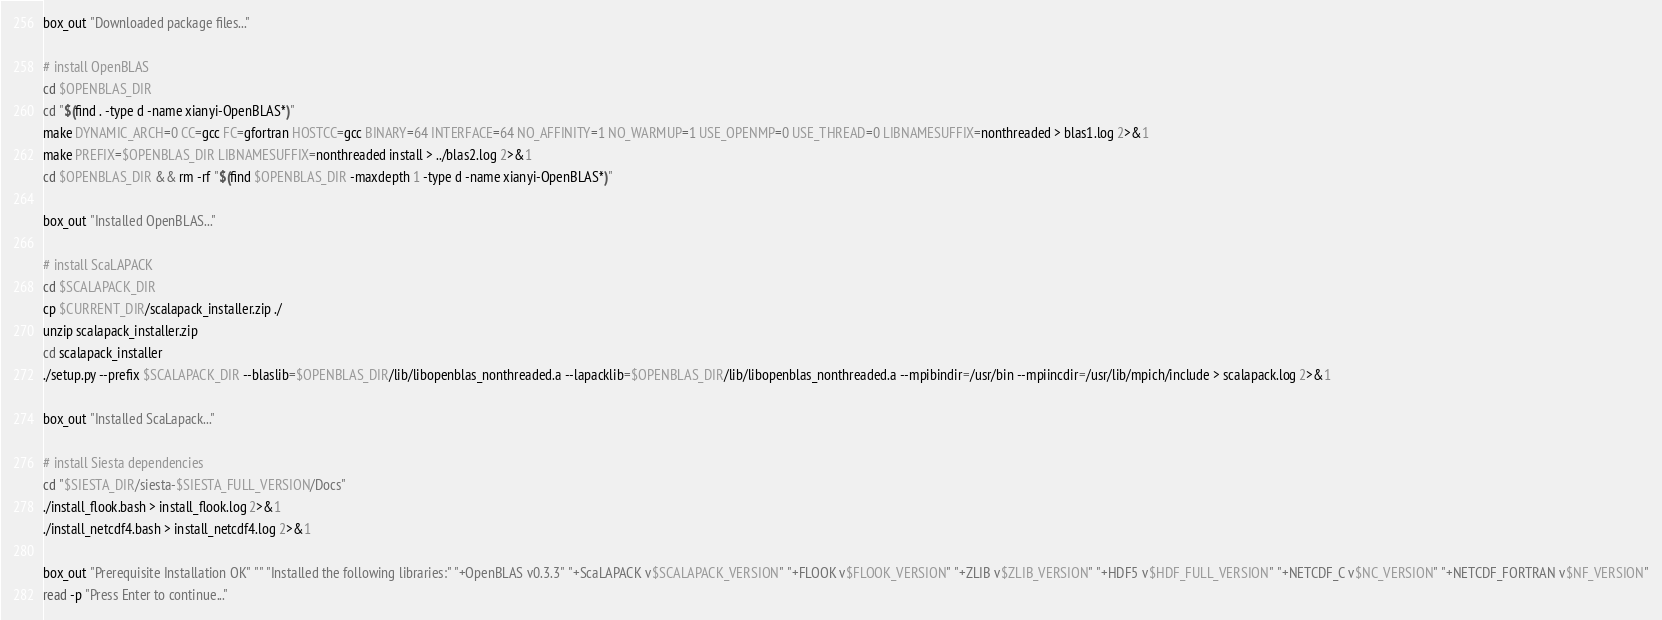Convert code to text. <code><loc_0><loc_0><loc_500><loc_500><_Bash_>box_out "Downloaded package files..."

# install OpenBLAS
cd $OPENBLAS_DIR
cd "$(find . -type d -name xianyi-OpenBLAS*)"
make DYNAMIC_ARCH=0 CC=gcc FC=gfortran HOSTCC=gcc BINARY=64 INTERFACE=64 NO_AFFINITY=1 NO_WARMUP=1 USE_OPENMP=0 USE_THREAD=0 LIBNAMESUFFIX=nonthreaded > blas1.log 2>&1
make PREFIX=$OPENBLAS_DIR LIBNAMESUFFIX=nonthreaded install > ../blas2.log 2>&1
cd $OPENBLAS_DIR && rm -rf "$(find $OPENBLAS_DIR -maxdepth 1 -type d -name xianyi-OpenBLAS*)"

box_out "Installed OpenBLAS..."

# install ScaLAPACK
cd $SCALAPACK_DIR
cp $CURRENT_DIR/scalapack_installer.zip ./
unzip scalapack_installer.zip
cd scalapack_installer
./setup.py --prefix $SCALAPACK_DIR --blaslib=$OPENBLAS_DIR/lib/libopenblas_nonthreaded.a --lapacklib=$OPENBLAS_DIR/lib/libopenblas_nonthreaded.a --mpibindir=/usr/bin --mpiincdir=/usr/lib/mpich/include > scalapack.log 2>&1

box_out "Installed ScaLapack..."

# install Siesta dependencies
cd "$SIESTA_DIR/siesta-$SIESTA_FULL_VERSION/Docs"
./install_flook.bash > install_flook.log 2>&1
./install_netcdf4.bash > install_netcdf4.log 2>&1

box_out "Prerequisite Installation OK" "" "Installed the following libraries:" "+OpenBLAS v0.3.3" "+ScaLAPACK v$SCALAPACK_VERSION" "+FLOOK v$FLOOK_VERSION" "+ZLIB v$ZLIB_VERSION" "+HDF5 v$HDF_FULL_VERSION" "+NETCDF_C v$NC_VERSION" "+NETCDF_FORTRAN v$NF_VERSION"
read -p "Press Enter to continue..."
</code> 